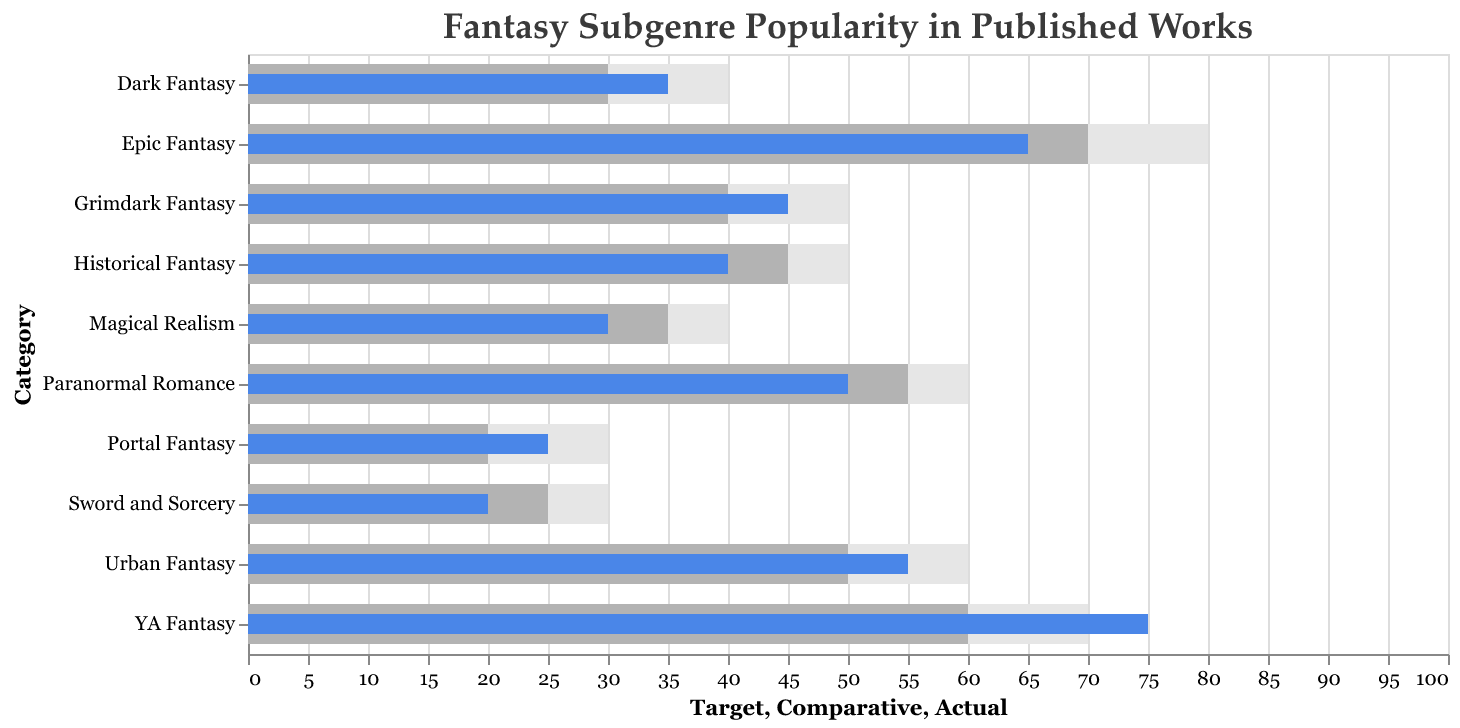What is the title of the chart? The title is generally found at the top of the chart. In this case, the title is "Fantasy Subgenre Popularity in Published Works".
Answer: Fantasy Subgenre Popularity in Published Works How many categories of fantasy subgenres are shown in the chart? By counting the number of unique subgenre names listed on the y-axis, we see that there are 10 categories.
Answer: 10 Which subgenre has the highest actual value? By looking at the blue bars (which indicate the actual values), we see that YA Fantasy has the longest blue bar, corresponding to an actual value of 75.
Answer: YA Fantasy Which subgenre has the largest gap between its actual and target values? To find the largest gap, subtract the Actual value from the Target value for each subgenre and compare. Epic Fantasy has the target of 80 and an actual value of 65, giving a gap of 15, which is the largest.
Answer: Epic Fantasy Which subgenre has an actual value closest to its target value? Subtract the actual value from the target value for each subgenre and identify the smallest absolute difference. Urban Fantasy has a target of 60 and an actual of 55, giving a difference of 5.
Answer: Urban Fantasy How does the actual value of Historical Fantasy compare to its comparative value? By looking at the respective bars for Historical Fantasy, the actual value (blue) is 40, and the comparative value (gray) is 45. Since 40 is less than 45, it shows that Historical Fantasy's actual value is less than its comparative value.
Answer: Less than What is the target value for Grimdark Fantasy, and how does it compare to its actual value? Looking at the bars for Grimdark Fantasy, the target value is 50, and the actual value is 45. Comparing these values, the actual value (45) is less than the target value (50).
Answer: 50, less than Which subgenres have an actual value greater than their comparative values? By comparing the blue and gray bars for each subgenre, we see that the subgenres where the actual value exceeds the comparative value are Epic Fantasy, YA Fantasy, Dark Fantasy, Urban Fantasy, and Grimdark Fantasy.
Answer: Epic Fantasy, YA Fantasy, Dark Fantasy, Urban Fantasy, Grimdark Fantasy What is the average actual value across all subgenres? First sum all the actual values: 65 + 55 + 75 + 40 + 35 + 25 + 30 + 50 + 20 + 45 = 440. Since there are 10 subgenres, divide the sum by 10. 440 / 10 = 44.
Answer: 44 